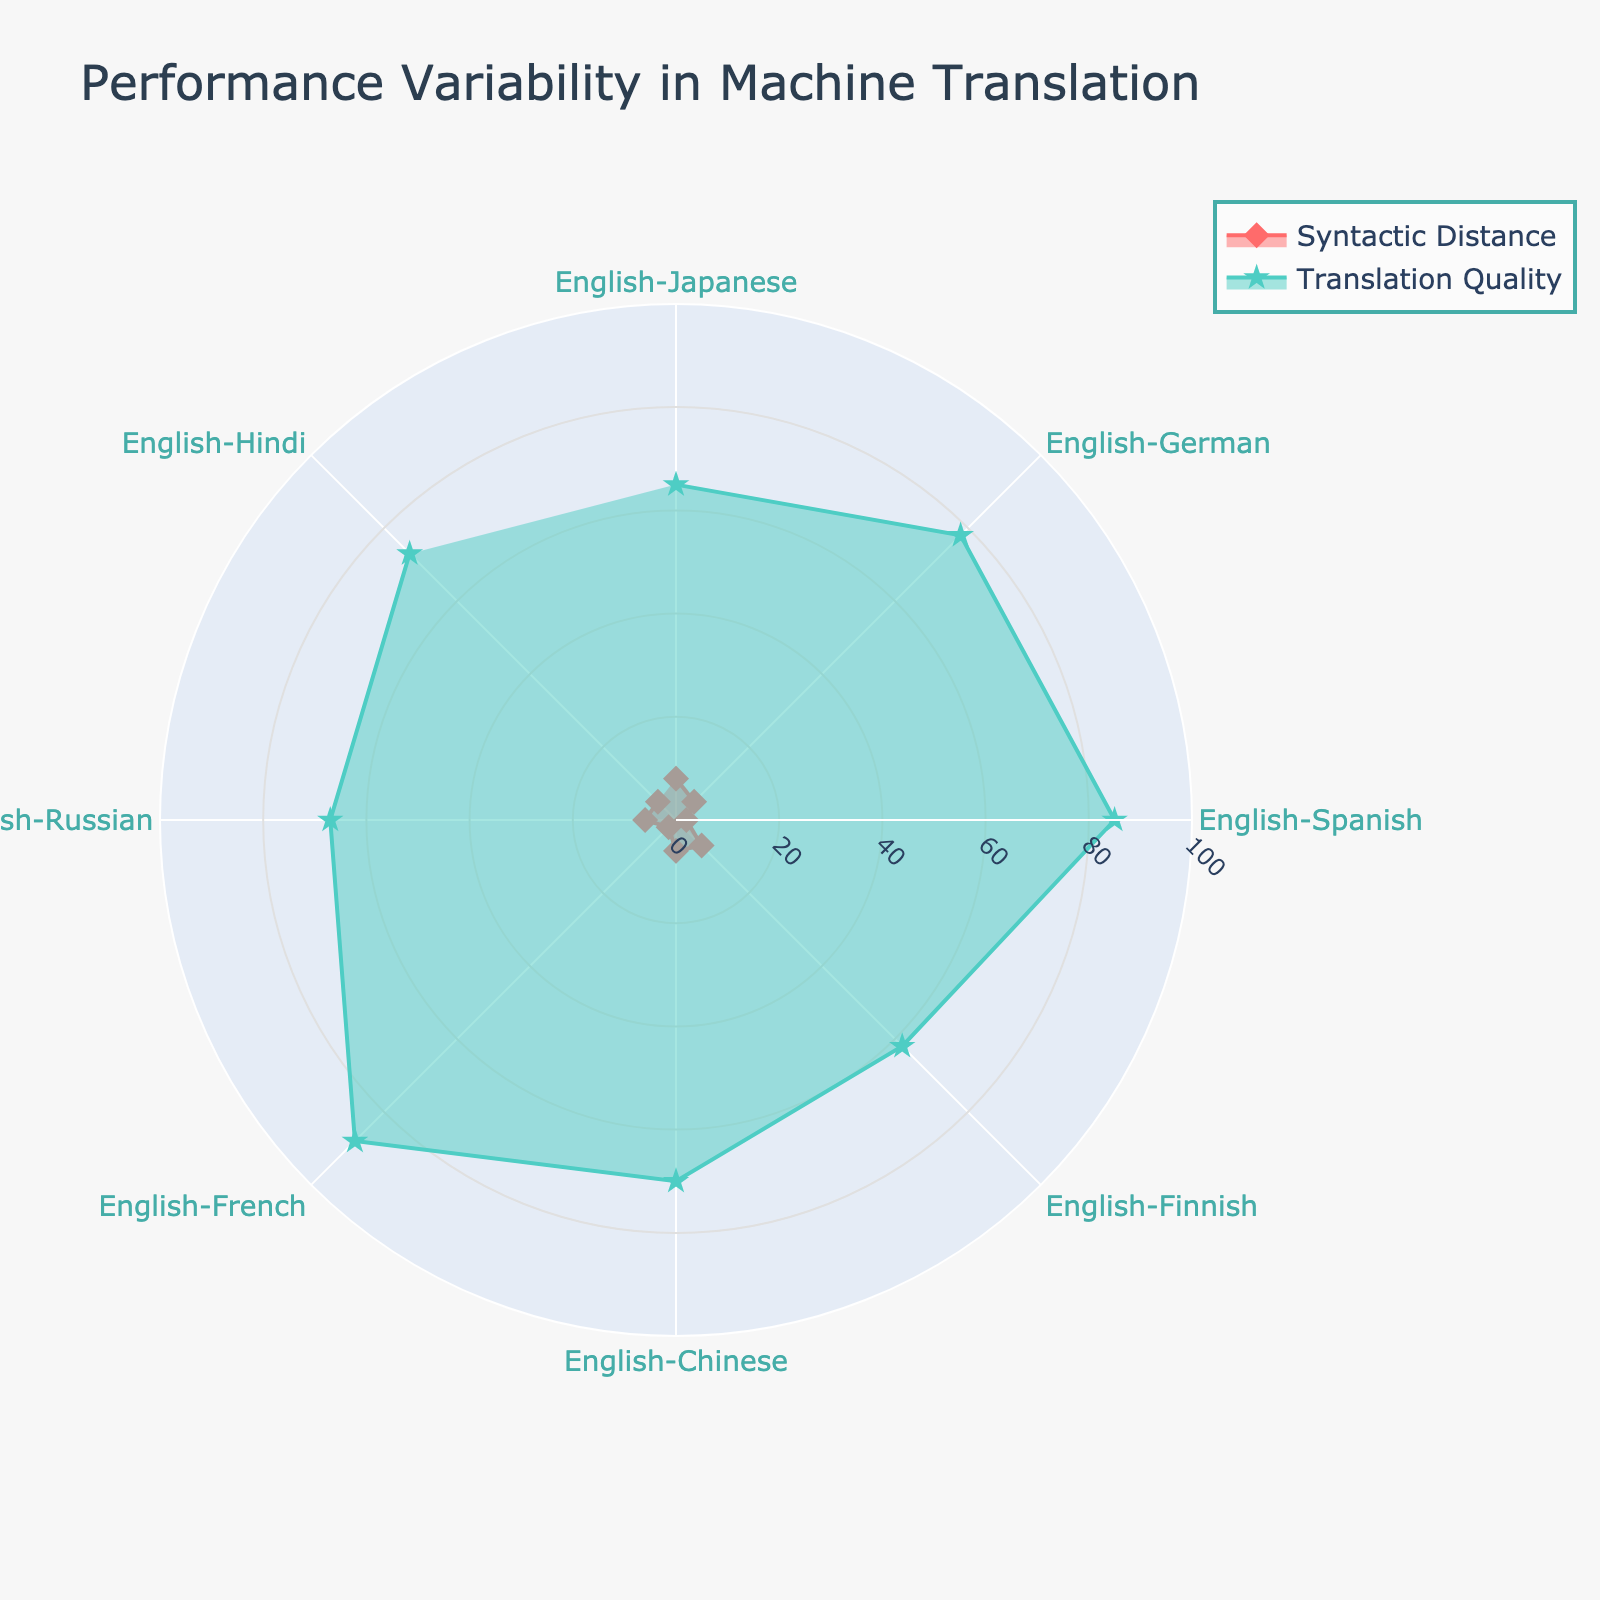What's the title of the chart? The title is usually displayed at the top center of the chart and in this case, it describes the main focus of the plot.
Answer: Performance Variability in Machine Translation What are the names of the two traces in the plot? The traces are usually named in the legend on the right side of the chart, which helps differentiate between the types of data being displayed.
Answer: Syntactic Distance and Translation Quality Which language pair has the highest translation quality? By looking at the outermost point on the 'Translation Quality' trace in the polar chart, we can identify the language pair with the highest value.
Answer: English-French What is the syntactic distance for the English-Hindi language pair? Locate the point corresponding to English-Hindi on the 'Syntactic Distance' trace (marked with a diamond symbol), and read off its radial value.
Answer: 5 How many language pairs have a syntactic distance greater than or equal to 6? Count the points on the 'Syntactic Distance' trace that have radial values of 6 or more. These points can be identified by their positioning further from the center.
Answer: 4 Which two language pairs have the lowest syntactic distance, and what are their respective translation qualities? Identify the points with the smallest radial values on the 'Syntactic Distance' trace. Then, compare their positions to those on the 'Translation Quality' trace.
Answer: English-Spanish and English-French; 85 and 88 Compare the translation quality of English-Japanese and English-German. Which one is higher and by how much? Locate the radial values for both English-Japanese and English-German on the 'Translation Quality' trace, and then calculate the difference between the two values.
Answer: English-German by 13 What is the average translation quality of all language pairs? Sum the translation quality values of all language pairs and then divide by the total number of language pairs.
Answer: 73.5 Which language pair shows the largest difference between syntactic distance and translation quality? Calculate the absolute difference between the values for each language pair, and identify the pair with the largest difference.
Answer: English-Finnish In which direction does the ‘Translation Quality’ trace largely move compared to the 'Syntactic Distance' trace among different language pairs? Analyze the positions and length of the 'Translation Quality' and 'Syntactic Distance' traces for all language pairs, focusing on how they relate visually to one another.
Answer: Translation Quality is generally higher than Syntactic Distance 